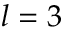<formula> <loc_0><loc_0><loc_500><loc_500>l = 3</formula> 